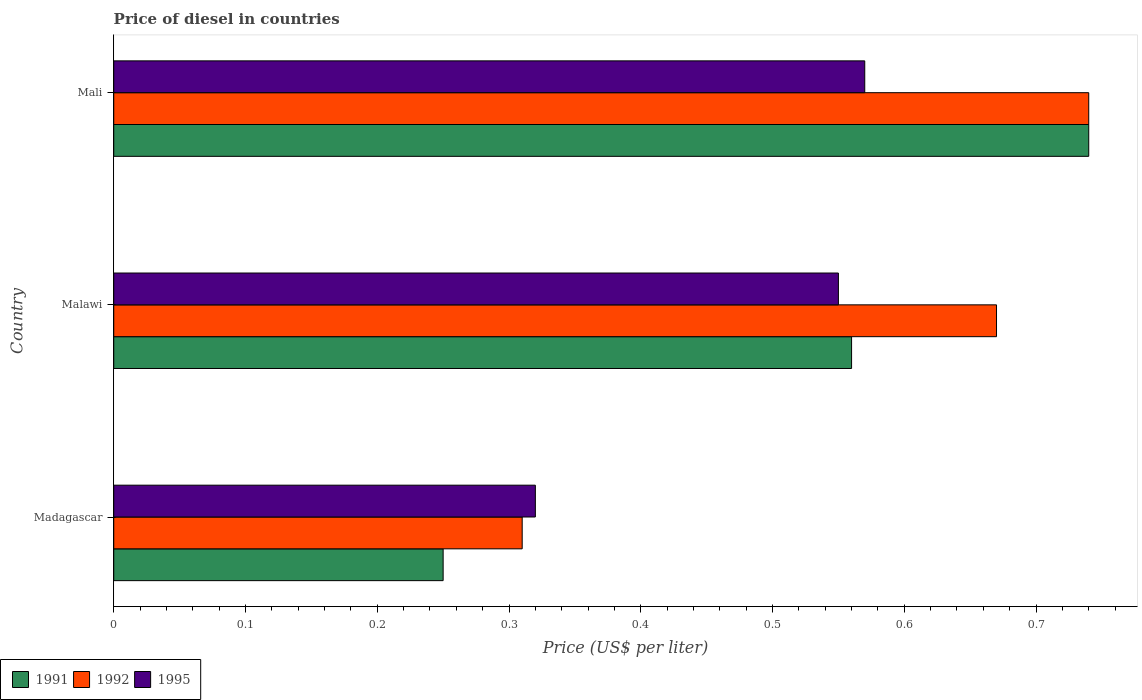Are the number of bars per tick equal to the number of legend labels?
Offer a terse response. Yes. Are the number of bars on each tick of the Y-axis equal?
Your answer should be compact. Yes. How many bars are there on the 1st tick from the top?
Ensure brevity in your answer.  3. What is the label of the 2nd group of bars from the top?
Your answer should be very brief. Malawi. What is the price of diesel in 1995 in Mali?
Offer a very short reply. 0.57. Across all countries, what is the maximum price of diesel in 1995?
Provide a succinct answer. 0.57. Across all countries, what is the minimum price of diesel in 1992?
Keep it short and to the point. 0.31. In which country was the price of diesel in 1991 maximum?
Offer a terse response. Mali. In which country was the price of diesel in 1992 minimum?
Provide a short and direct response. Madagascar. What is the total price of diesel in 1991 in the graph?
Keep it short and to the point. 1.55. What is the difference between the price of diesel in 1992 in Madagascar and that in Malawi?
Keep it short and to the point. -0.36. What is the difference between the price of diesel in 1995 in Malawi and the price of diesel in 1992 in Madagascar?
Your answer should be compact. 0.24. What is the average price of diesel in 1991 per country?
Provide a succinct answer. 0.52. What is the difference between the price of diesel in 1995 and price of diesel in 1991 in Malawi?
Make the answer very short. -0.01. In how many countries, is the price of diesel in 1992 greater than 0.52 US$?
Keep it short and to the point. 2. What is the ratio of the price of diesel in 1995 in Madagascar to that in Mali?
Your answer should be very brief. 0.56. Is the price of diesel in 1992 in Madagascar less than that in Mali?
Your answer should be compact. Yes. Is the difference between the price of diesel in 1995 in Malawi and Mali greater than the difference between the price of diesel in 1991 in Malawi and Mali?
Your response must be concise. Yes. What is the difference between the highest and the second highest price of diesel in 1995?
Make the answer very short. 0.02. What is the difference between the highest and the lowest price of diesel in 1995?
Offer a terse response. 0.25. Is the sum of the price of diesel in 1991 in Malawi and Mali greater than the maximum price of diesel in 1992 across all countries?
Your response must be concise. Yes. What does the 1st bar from the top in Madagascar represents?
Provide a short and direct response. 1995. Is it the case that in every country, the sum of the price of diesel in 1995 and price of diesel in 1991 is greater than the price of diesel in 1992?
Your answer should be very brief. Yes. Are all the bars in the graph horizontal?
Your answer should be very brief. Yes. How many countries are there in the graph?
Your answer should be very brief. 3. What is the difference between two consecutive major ticks on the X-axis?
Provide a succinct answer. 0.1. Are the values on the major ticks of X-axis written in scientific E-notation?
Provide a succinct answer. No. Does the graph contain any zero values?
Offer a very short reply. No. How many legend labels are there?
Ensure brevity in your answer.  3. What is the title of the graph?
Provide a succinct answer. Price of diesel in countries. What is the label or title of the X-axis?
Offer a terse response. Price (US$ per liter). What is the Price (US$ per liter) in 1991 in Madagascar?
Keep it short and to the point. 0.25. What is the Price (US$ per liter) of 1992 in Madagascar?
Ensure brevity in your answer.  0.31. What is the Price (US$ per liter) of 1995 in Madagascar?
Provide a short and direct response. 0.32. What is the Price (US$ per liter) in 1991 in Malawi?
Provide a succinct answer. 0.56. What is the Price (US$ per liter) in 1992 in Malawi?
Your answer should be compact. 0.67. What is the Price (US$ per liter) in 1995 in Malawi?
Keep it short and to the point. 0.55. What is the Price (US$ per liter) of 1991 in Mali?
Offer a very short reply. 0.74. What is the Price (US$ per liter) in 1992 in Mali?
Offer a terse response. 0.74. What is the Price (US$ per liter) of 1995 in Mali?
Keep it short and to the point. 0.57. Across all countries, what is the maximum Price (US$ per liter) of 1991?
Provide a succinct answer. 0.74. Across all countries, what is the maximum Price (US$ per liter) in 1992?
Give a very brief answer. 0.74. Across all countries, what is the maximum Price (US$ per liter) of 1995?
Offer a very short reply. 0.57. Across all countries, what is the minimum Price (US$ per liter) in 1991?
Provide a short and direct response. 0.25. Across all countries, what is the minimum Price (US$ per liter) in 1992?
Your answer should be compact. 0.31. Across all countries, what is the minimum Price (US$ per liter) of 1995?
Your answer should be very brief. 0.32. What is the total Price (US$ per liter) of 1991 in the graph?
Provide a short and direct response. 1.55. What is the total Price (US$ per liter) in 1992 in the graph?
Offer a very short reply. 1.72. What is the total Price (US$ per liter) in 1995 in the graph?
Your answer should be very brief. 1.44. What is the difference between the Price (US$ per liter) of 1991 in Madagascar and that in Malawi?
Offer a very short reply. -0.31. What is the difference between the Price (US$ per liter) of 1992 in Madagascar and that in Malawi?
Your answer should be very brief. -0.36. What is the difference between the Price (US$ per liter) of 1995 in Madagascar and that in Malawi?
Give a very brief answer. -0.23. What is the difference between the Price (US$ per liter) of 1991 in Madagascar and that in Mali?
Keep it short and to the point. -0.49. What is the difference between the Price (US$ per liter) of 1992 in Madagascar and that in Mali?
Provide a succinct answer. -0.43. What is the difference between the Price (US$ per liter) of 1995 in Madagascar and that in Mali?
Ensure brevity in your answer.  -0.25. What is the difference between the Price (US$ per liter) in 1991 in Malawi and that in Mali?
Your answer should be compact. -0.18. What is the difference between the Price (US$ per liter) in 1992 in Malawi and that in Mali?
Your answer should be compact. -0.07. What is the difference between the Price (US$ per liter) in 1995 in Malawi and that in Mali?
Offer a very short reply. -0.02. What is the difference between the Price (US$ per liter) in 1991 in Madagascar and the Price (US$ per liter) in 1992 in Malawi?
Offer a very short reply. -0.42. What is the difference between the Price (US$ per liter) in 1991 in Madagascar and the Price (US$ per liter) in 1995 in Malawi?
Provide a short and direct response. -0.3. What is the difference between the Price (US$ per liter) of 1992 in Madagascar and the Price (US$ per liter) of 1995 in Malawi?
Your response must be concise. -0.24. What is the difference between the Price (US$ per liter) in 1991 in Madagascar and the Price (US$ per liter) in 1992 in Mali?
Your response must be concise. -0.49. What is the difference between the Price (US$ per liter) of 1991 in Madagascar and the Price (US$ per liter) of 1995 in Mali?
Give a very brief answer. -0.32. What is the difference between the Price (US$ per liter) of 1992 in Madagascar and the Price (US$ per liter) of 1995 in Mali?
Offer a very short reply. -0.26. What is the difference between the Price (US$ per liter) of 1991 in Malawi and the Price (US$ per liter) of 1992 in Mali?
Provide a succinct answer. -0.18. What is the difference between the Price (US$ per liter) in 1991 in Malawi and the Price (US$ per liter) in 1995 in Mali?
Your response must be concise. -0.01. What is the average Price (US$ per liter) in 1991 per country?
Ensure brevity in your answer.  0.52. What is the average Price (US$ per liter) of 1992 per country?
Keep it short and to the point. 0.57. What is the average Price (US$ per liter) in 1995 per country?
Offer a very short reply. 0.48. What is the difference between the Price (US$ per liter) in 1991 and Price (US$ per liter) in 1992 in Madagascar?
Ensure brevity in your answer.  -0.06. What is the difference between the Price (US$ per liter) of 1991 and Price (US$ per liter) of 1995 in Madagascar?
Give a very brief answer. -0.07. What is the difference between the Price (US$ per liter) of 1992 and Price (US$ per liter) of 1995 in Madagascar?
Make the answer very short. -0.01. What is the difference between the Price (US$ per liter) of 1991 and Price (US$ per liter) of 1992 in Malawi?
Give a very brief answer. -0.11. What is the difference between the Price (US$ per liter) in 1991 and Price (US$ per liter) in 1995 in Malawi?
Provide a succinct answer. 0.01. What is the difference between the Price (US$ per liter) of 1992 and Price (US$ per liter) of 1995 in Malawi?
Provide a short and direct response. 0.12. What is the difference between the Price (US$ per liter) of 1991 and Price (US$ per liter) of 1995 in Mali?
Make the answer very short. 0.17. What is the difference between the Price (US$ per liter) of 1992 and Price (US$ per liter) of 1995 in Mali?
Your answer should be compact. 0.17. What is the ratio of the Price (US$ per liter) of 1991 in Madagascar to that in Malawi?
Your answer should be compact. 0.45. What is the ratio of the Price (US$ per liter) in 1992 in Madagascar to that in Malawi?
Keep it short and to the point. 0.46. What is the ratio of the Price (US$ per liter) in 1995 in Madagascar to that in Malawi?
Offer a very short reply. 0.58. What is the ratio of the Price (US$ per liter) of 1991 in Madagascar to that in Mali?
Offer a terse response. 0.34. What is the ratio of the Price (US$ per liter) of 1992 in Madagascar to that in Mali?
Keep it short and to the point. 0.42. What is the ratio of the Price (US$ per liter) of 1995 in Madagascar to that in Mali?
Provide a short and direct response. 0.56. What is the ratio of the Price (US$ per liter) of 1991 in Malawi to that in Mali?
Provide a succinct answer. 0.76. What is the ratio of the Price (US$ per liter) of 1992 in Malawi to that in Mali?
Offer a very short reply. 0.91. What is the ratio of the Price (US$ per liter) in 1995 in Malawi to that in Mali?
Provide a short and direct response. 0.96. What is the difference between the highest and the second highest Price (US$ per liter) of 1991?
Provide a succinct answer. 0.18. What is the difference between the highest and the second highest Price (US$ per liter) of 1992?
Ensure brevity in your answer.  0.07. What is the difference between the highest and the second highest Price (US$ per liter) in 1995?
Keep it short and to the point. 0.02. What is the difference between the highest and the lowest Price (US$ per liter) of 1991?
Provide a succinct answer. 0.49. What is the difference between the highest and the lowest Price (US$ per liter) in 1992?
Keep it short and to the point. 0.43. 